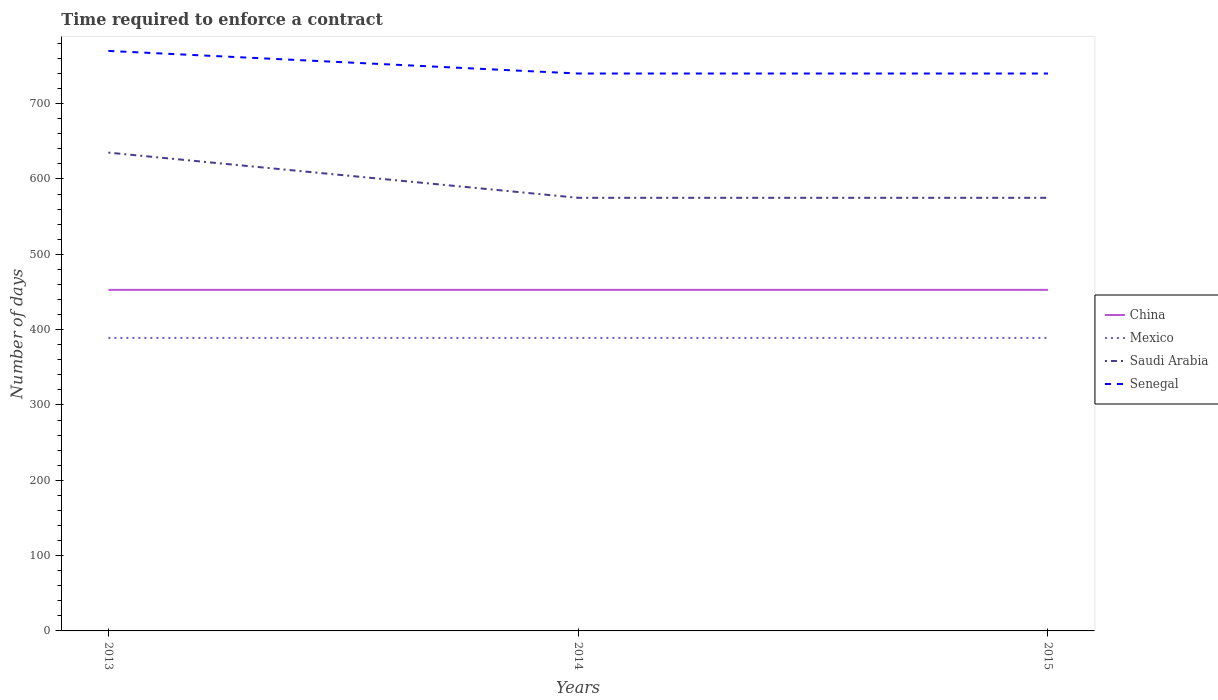Across all years, what is the maximum number of days required to enforce a contract in Mexico?
Your answer should be compact. 389. What is the difference between the highest and the second highest number of days required to enforce a contract in China?
Provide a short and direct response. 0. What is the difference between two consecutive major ticks on the Y-axis?
Offer a very short reply. 100. Are the values on the major ticks of Y-axis written in scientific E-notation?
Ensure brevity in your answer.  No. Does the graph contain any zero values?
Ensure brevity in your answer.  No. How many legend labels are there?
Your response must be concise. 4. What is the title of the graph?
Your answer should be very brief. Time required to enforce a contract. What is the label or title of the X-axis?
Give a very brief answer. Years. What is the label or title of the Y-axis?
Provide a succinct answer. Number of days. What is the Number of days of China in 2013?
Your answer should be very brief. 452.8. What is the Number of days in Mexico in 2013?
Ensure brevity in your answer.  389. What is the Number of days of Saudi Arabia in 2013?
Your answer should be very brief. 635. What is the Number of days of Senegal in 2013?
Your response must be concise. 770. What is the Number of days of China in 2014?
Make the answer very short. 452.8. What is the Number of days of Mexico in 2014?
Your answer should be compact. 389. What is the Number of days in Saudi Arabia in 2014?
Make the answer very short. 575. What is the Number of days of Senegal in 2014?
Make the answer very short. 740. What is the Number of days in China in 2015?
Provide a short and direct response. 452.8. What is the Number of days in Mexico in 2015?
Provide a short and direct response. 389. What is the Number of days in Saudi Arabia in 2015?
Your answer should be compact. 575. What is the Number of days in Senegal in 2015?
Your answer should be very brief. 740. Across all years, what is the maximum Number of days of China?
Offer a terse response. 452.8. Across all years, what is the maximum Number of days of Mexico?
Provide a short and direct response. 389. Across all years, what is the maximum Number of days of Saudi Arabia?
Your answer should be compact. 635. Across all years, what is the maximum Number of days in Senegal?
Offer a terse response. 770. Across all years, what is the minimum Number of days in China?
Your answer should be compact. 452.8. Across all years, what is the minimum Number of days of Mexico?
Your response must be concise. 389. Across all years, what is the minimum Number of days in Saudi Arabia?
Make the answer very short. 575. Across all years, what is the minimum Number of days of Senegal?
Ensure brevity in your answer.  740. What is the total Number of days of China in the graph?
Provide a succinct answer. 1358.4. What is the total Number of days in Mexico in the graph?
Provide a short and direct response. 1167. What is the total Number of days in Saudi Arabia in the graph?
Your answer should be compact. 1785. What is the total Number of days of Senegal in the graph?
Ensure brevity in your answer.  2250. What is the difference between the Number of days in Mexico in 2013 and that in 2014?
Make the answer very short. 0. What is the difference between the Number of days in China in 2013 and that in 2015?
Provide a succinct answer. 0. What is the difference between the Number of days of Mexico in 2013 and that in 2015?
Provide a succinct answer. 0. What is the difference between the Number of days of Saudi Arabia in 2013 and that in 2015?
Make the answer very short. 60. What is the difference between the Number of days in China in 2014 and that in 2015?
Provide a succinct answer. 0. What is the difference between the Number of days in Saudi Arabia in 2014 and that in 2015?
Offer a terse response. 0. What is the difference between the Number of days in Senegal in 2014 and that in 2015?
Give a very brief answer. 0. What is the difference between the Number of days in China in 2013 and the Number of days in Mexico in 2014?
Keep it short and to the point. 63.8. What is the difference between the Number of days in China in 2013 and the Number of days in Saudi Arabia in 2014?
Provide a succinct answer. -122.2. What is the difference between the Number of days of China in 2013 and the Number of days of Senegal in 2014?
Give a very brief answer. -287.2. What is the difference between the Number of days in Mexico in 2013 and the Number of days in Saudi Arabia in 2014?
Give a very brief answer. -186. What is the difference between the Number of days of Mexico in 2013 and the Number of days of Senegal in 2014?
Ensure brevity in your answer.  -351. What is the difference between the Number of days of Saudi Arabia in 2013 and the Number of days of Senegal in 2014?
Offer a very short reply. -105. What is the difference between the Number of days in China in 2013 and the Number of days in Mexico in 2015?
Provide a succinct answer. 63.8. What is the difference between the Number of days in China in 2013 and the Number of days in Saudi Arabia in 2015?
Your answer should be compact. -122.2. What is the difference between the Number of days of China in 2013 and the Number of days of Senegal in 2015?
Make the answer very short. -287.2. What is the difference between the Number of days of Mexico in 2013 and the Number of days of Saudi Arabia in 2015?
Offer a terse response. -186. What is the difference between the Number of days in Mexico in 2013 and the Number of days in Senegal in 2015?
Your answer should be very brief. -351. What is the difference between the Number of days of Saudi Arabia in 2013 and the Number of days of Senegal in 2015?
Keep it short and to the point. -105. What is the difference between the Number of days of China in 2014 and the Number of days of Mexico in 2015?
Ensure brevity in your answer.  63.8. What is the difference between the Number of days of China in 2014 and the Number of days of Saudi Arabia in 2015?
Offer a very short reply. -122.2. What is the difference between the Number of days of China in 2014 and the Number of days of Senegal in 2015?
Provide a short and direct response. -287.2. What is the difference between the Number of days of Mexico in 2014 and the Number of days of Saudi Arabia in 2015?
Your answer should be compact. -186. What is the difference between the Number of days in Mexico in 2014 and the Number of days in Senegal in 2015?
Make the answer very short. -351. What is the difference between the Number of days in Saudi Arabia in 2014 and the Number of days in Senegal in 2015?
Offer a very short reply. -165. What is the average Number of days in China per year?
Offer a very short reply. 452.8. What is the average Number of days in Mexico per year?
Your answer should be very brief. 389. What is the average Number of days of Saudi Arabia per year?
Make the answer very short. 595. What is the average Number of days in Senegal per year?
Your answer should be compact. 750. In the year 2013, what is the difference between the Number of days of China and Number of days of Mexico?
Provide a succinct answer. 63.8. In the year 2013, what is the difference between the Number of days in China and Number of days in Saudi Arabia?
Your answer should be very brief. -182.2. In the year 2013, what is the difference between the Number of days of China and Number of days of Senegal?
Give a very brief answer. -317.2. In the year 2013, what is the difference between the Number of days in Mexico and Number of days in Saudi Arabia?
Offer a terse response. -246. In the year 2013, what is the difference between the Number of days of Mexico and Number of days of Senegal?
Provide a succinct answer. -381. In the year 2013, what is the difference between the Number of days in Saudi Arabia and Number of days in Senegal?
Your answer should be compact. -135. In the year 2014, what is the difference between the Number of days in China and Number of days in Mexico?
Make the answer very short. 63.8. In the year 2014, what is the difference between the Number of days in China and Number of days in Saudi Arabia?
Your answer should be compact. -122.2. In the year 2014, what is the difference between the Number of days of China and Number of days of Senegal?
Keep it short and to the point. -287.2. In the year 2014, what is the difference between the Number of days of Mexico and Number of days of Saudi Arabia?
Provide a succinct answer. -186. In the year 2014, what is the difference between the Number of days of Mexico and Number of days of Senegal?
Offer a terse response. -351. In the year 2014, what is the difference between the Number of days of Saudi Arabia and Number of days of Senegal?
Offer a terse response. -165. In the year 2015, what is the difference between the Number of days in China and Number of days in Mexico?
Your response must be concise. 63.8. In the year 2015, what is the difference between the Number of days in China and Number of days in Saudi Arabia?
Your answer should be very brief. -122.2. In the year 2015, what is the difference between the Number of days of China and Number of days of Senegal?
Offer a very short reply. -287.2. In the year 2015, what is the difference between the Number of days in Mexico and Number of days in Saudi Arabia?
Give a very brief answer. -186. In the year 2015, what is the difference between the Number of days of Mexico and Number of days of Senegal?
Keep it short and to the point. -351. In the year 2015, what is the difference between the Number of days of Saudi Arabia and Number of days of Senegal?
Ensure brevity in your answer.  -165. What is the ratio of the Number of days of China in 2013 to that in 2014?
Give a very brief answer. 1. What is the ratio of the Number of days in Saudi Arabia in 2013 to that in 2014?
Offer a very short reply. 1.1. What is the ratio of the Number of days of Senegal in 2013 to that in 2014?
Offer a terse response. 1.04. What is the ratio of the Number of days of China in 2013 to that in 2015?
Keep it short and to the point. 1. What is the ratio of the Number of days of Saudi Arabia in 2013 to that in 2015?
Offer a terse response. 1.1. What is the ratio of the Number of days of Senegal in 2013 to that in 2015?
Make the answer very short. 1.04. What is the ratio of the Number of days in Saudi Arabia in 2014 to that in 2015?
Your answer should be very brief. 1. What is the difference between the highest and the second highest Number of days in Mexico?
Offer a terse response. 0. What is the difference between the highest and the lowest Number of days of China?
Provide a short and direct response. 0. What is the difference between the highest and the lowest Number of days of Saudi Arabia?
Give a very brief answer. 60. 